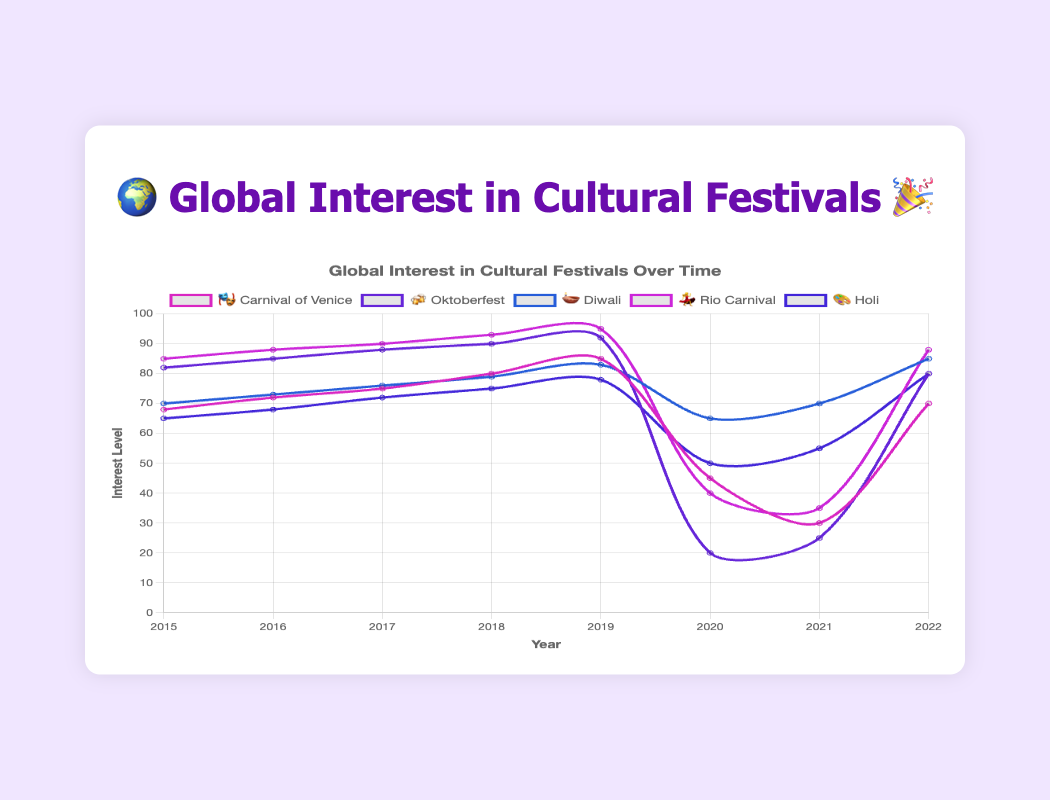What is the overall trend in interest for the "Rio Carnival" 💃 from 2015 to 2022? The interest for the Rio Carnival increased from 2015 to 2019. It then dropped sharply in 2020 and 2021 before rising again in 2022.
Answer: Mixed trend Which festival had the lowest interest in 2020? By observing the interests in 2020, Oktoberfest 🍻 had the lowest interest level of 20.
Answer: Oktoberfest 🍻 Which two festivals had the highest interest in 2019? In 2019, Rio Carnival 💃 had the highest interest at 95, followed by Oktoberfest 🍻 with an interest of 92.
Answer: Rio Carnival 💃 and Oktoberfest 🍻 What was the interest level of "Diwali" 🪔 in 2017? By looking at the data points, the interest level for Diwali 🪔 in 2017 was 76.
Answer: 76 How did the interest in "Holi" 🎨 change from 2020 to 2021? The interest in Holi 🎨 increased from 50 in 2020 to 55 in 2021.
Answer: Increased Compare the interest drop for "Carnival of Venice" 🎭 and "Rio Carnival" 💃 between 2019 and 2020. Which dropped more? Carnival of Venice 🎭 dropped from 85 to 45, a decrease of 40 points. Rio Carnival 💃 dropped from 95 to 40, a decrease of 55 points. Thus, Rio Carnival 💃 had a larger drop in interest.
Answer: Rio Carnival 💃 Which festival had a consistent increase in interest from 2015 to 2019? Both Diwali 🪔 and Rio Carnival 💃 show a consistent increase in interest from 2015 to 2019.
Answer: Diwali 🪔 and Rio Carnival 💃 Which festival had the least interest in 2021? In 2021, Carnival of Venice 🎭 had the least interest with an interest level of 30.
Answer: Carnival of Venice 🎭 What is the average interest of "Oktoberfest" 🍻 from 2015 to 2022? Sum up the interest values of Oktoberfest 🍻 (82, 85, 88, 90, 92, 20, 25, 80) which equals 562, then divide by the number of years (8). So, 562/8 = 70.25.
Answer: 70.25 